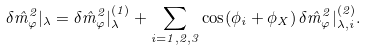<formula> <loc_0><loc_0><loc_500><loc_500>\delta \hat { m } _ { \varphi } ^ { 2 } | _ { \lambda } = \delta \hat { m } _ { \varphi } ^ { 2 } | _ { \lambda } ^ { ( 1 ) } + \sum _ { i = 1 , 2 , 3 } \cos ( \phi _ { i } + \phi _ { X } ) \, \delta \hat { m } _ { \varphi } ^ { 2 } | _ { \lambda , i } ^ { ( 2 ) } .</formula> 